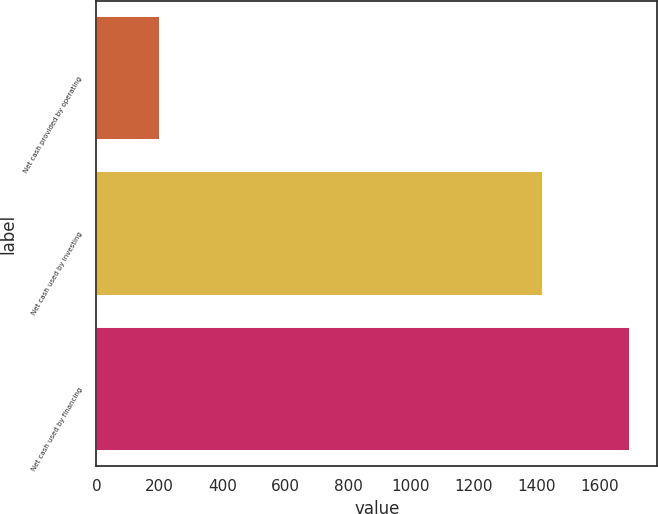Convert chart to OTSL. <chart><loc_0><loc_0><loc_500><loc_500><bar_chart><fcel>Net cash provided by operating<fcel>Net cash used by investing<fcel>Net cash used by financing<nl><fcel>201<fcel>1418<fcel>1697<nl></chart> 